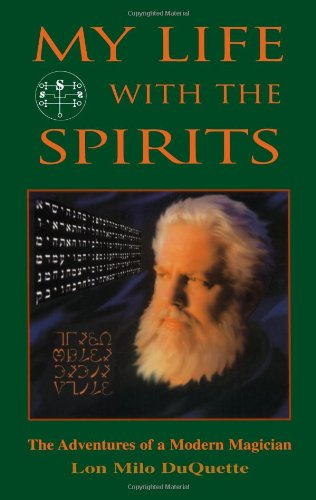Is this an art related book? No, this book primarily revolves around the personal and spiritual experiences of the author with magical practices, rather than focusing on art or visual aesthetics. 